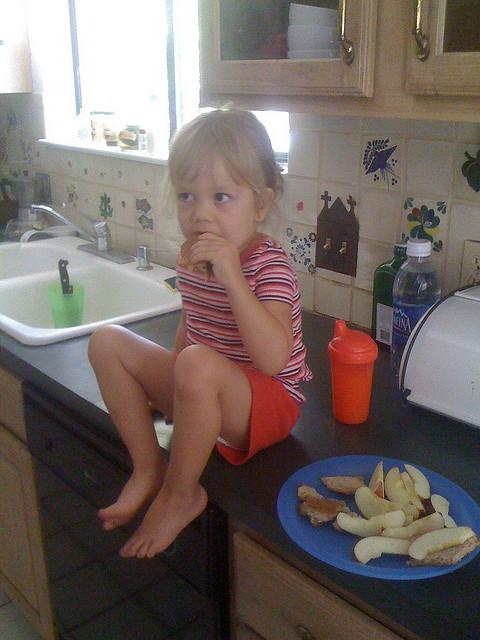What is a danger to the child? Please explain your reasoning. sharp knife. There is a sharp knife in the sink which could be dangerous. 